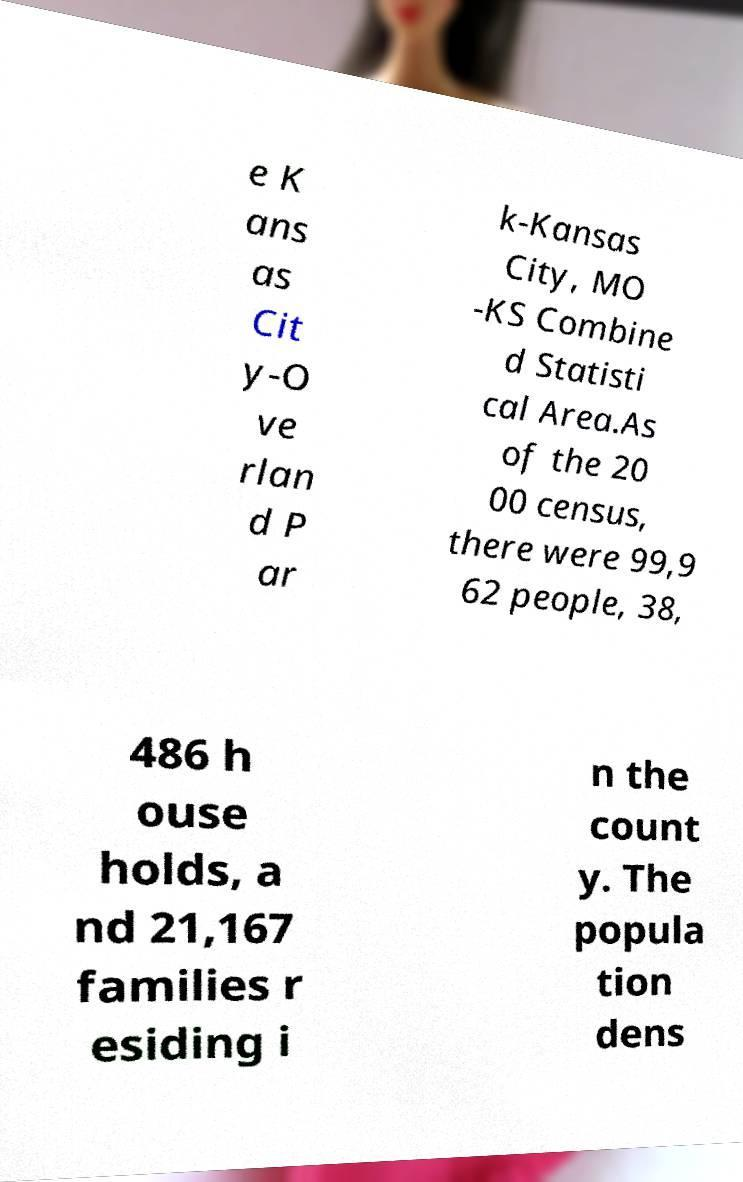Please identify and transcribe the text found in this image. e K ans as Cit y-O ve rlan d P ar k-Kansas City, MO -KS Combine d Statisti cal Area.As of the 20 00 census, there were 99,9 62 people, 38, 486 h ouse holds, a nd 21,167 families r esiding i n the count y. The popula tion dens 